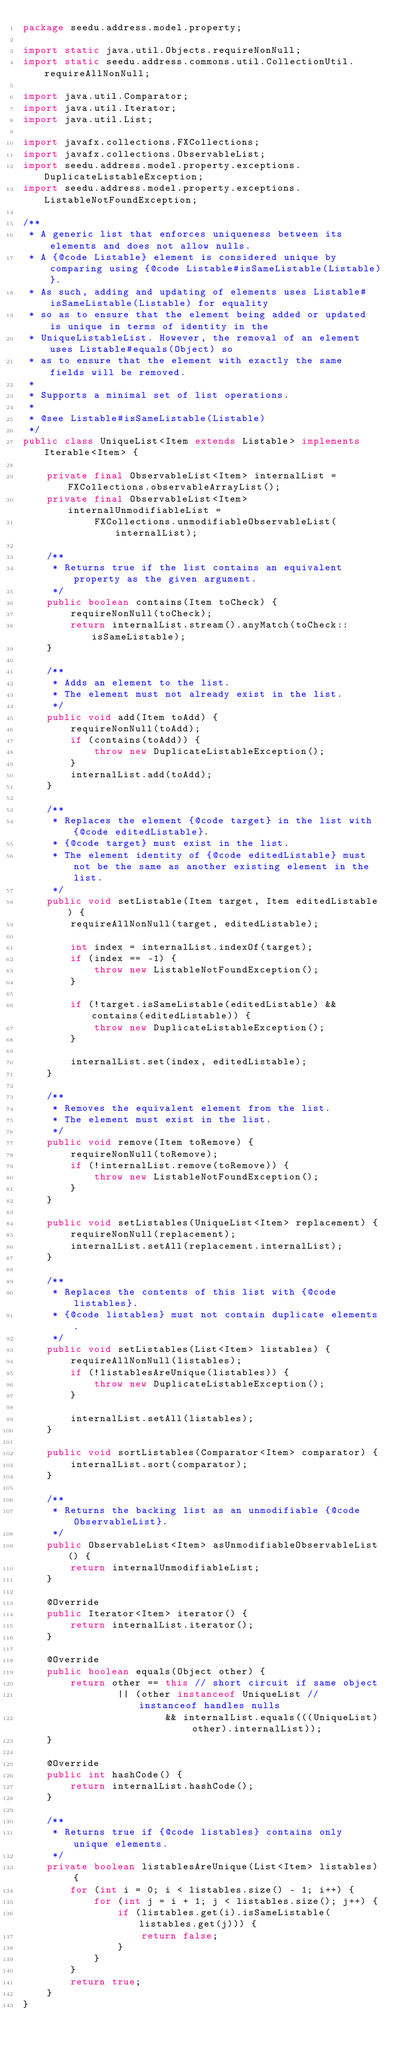Convert code to text. <code><loc_0><loc_0><loc_500><loc_500><_Java_>package seedu.address.model.property;

import static java.util.Objects.requireNonNull;
import static seedu.address.commons.util.CollectionUtil.requireAllNonNull;

import java.util.Comparator;
import java.util.Iterator;
import java.util.List;

import javafx.collections.FXCollections;
import javafx.collections.ObservableList;
import seedu.address.model.property.exceptions.DuplicateListableException;
import seedu.address.model.property.exceptions.ListableNotFoundException;

/**
 * A generic list that enforces uniqueness between its elements and does not allow nulls.
 * A {@code Listable} element is considered unique by comparing using {@code Listable#isSameListable(Listable)}.
 * As such, adding and updating of elements uses Listable#isSameListable(Listable) for equality
 * so as to ensure that the element being added or updated is unique in terms of identity in the
 * UniqueListableList. However, the removal of an element uses Listable#equals(Object) so
 * as to ensure that the element with exactly the same fields will be removed.
 *
 * Supports a minimal set of list operations.
 *
 * @see Listable#isSameListable(Listable)
 */
public class UniqueList<Item extends Listable> implements Iterable<Item> {

    private final ObservableList<Item> internalList = FXCollections.observableArrayList();
    private final ObservableList<Item> internalUnmodifiableList =
            FXCollections.unmodifiableObservableList(internalList);

    /**
     * Returns true if the list contains an equivalent property as the given argument.
     */
    public boolean contains(Item toCheck) {
        requireNonNull(toCheck);
        return internalList.stream().anyMatch(toCheck::isSameListable);
    }

    /**
     * Adds an element to the list.
     * The element must not already exist in the list.
     */
    public void add(Item toAdd) {
        requireNonNull(toAdd);
        if (contains(toAdd)) {
            throw new DuplicateListableException();
        }
        internalList.add(toAdd);
    }

    /**
     * Replaces the element {@code target} in the list with {@code editedListable}.
     * {@code target} must exist in the list.
     * The element identity of {@code editedListable} must not be the same as another existing element in the list.
     */
    public void setListable(Item target, Item editedListable) {
        requireAllNonNull(target, editedListable);

        int index = internalList.indexOf(target);
        if (index == -1) {
            throw new ListableNotFoundException();
        }

        if (!target.isSameListable(editedListable) && contains(editedListable)) {
            throw new DuplicateListableException();
        }

        internalList.set(index, editedListable);
    }

    /**
     * Removes the equivalent element from the list.
     * The element must exist in the list.
     */
    public void remove(Item toRemove) {
        requireNonNull(toRemove);
        if (!internalList.remove(toRemove)) {
            throw new ListableNotFoundException();
        }
    }

    public void setListables(UniqueList<Item> replacement) {
        requireNonNull(replacement);
        internalList.setAll(replacement.internalList);
    }

    /**
     * Replaces the contents of this list with {@code listables}.
     * {@code listables} must not contain duplicate elements.
     */
    public void setListables(List<Item> listables) {
        requireAllNonNull(listables);
        if (!listablesAreUnique(listables)) {
            throw new DuplicateListableException();
        }

        internalList.setAll(listables);
    }

    public void sortListables(Comparator<Item> comparator) {
        internalList.sort(comparator);
    }

    /**
     * Returns the backing list as an unmodifiable {@code ObservableList}.
     */
    public ObservableList<Item> asUnmodifiableObservableList() {
        return internalUnmodifiableList;
    }

    @Override
    public Iterator<Item> iterator() {
        return internalList.iterator();
    }

    @Override
    public boolean equals(Object other) {
        return other == this // short circuit if same object
                || (other instanceof UniqueList // instanceof handles nulls
                        && internalList.equals(((UniqueList) other).internalList));
    }

    @Override
    public int hashCode() {
        return internalList.hashCode();
    }

    /**
     * Returns true if {@code listables} contains only unique elements.
     */
    private boolean listablesAreUnique(List<Item> listables) {
        for (int i = 0; i < listables.size() - 1; i++) {
            for (int j = i + 1; j < listables.size(); j++) {
                if (listables.get(i).isSameListable(listables.get(j))) {
                    return false;
                }
            }
        }
        return true;
    }
}
</code> 